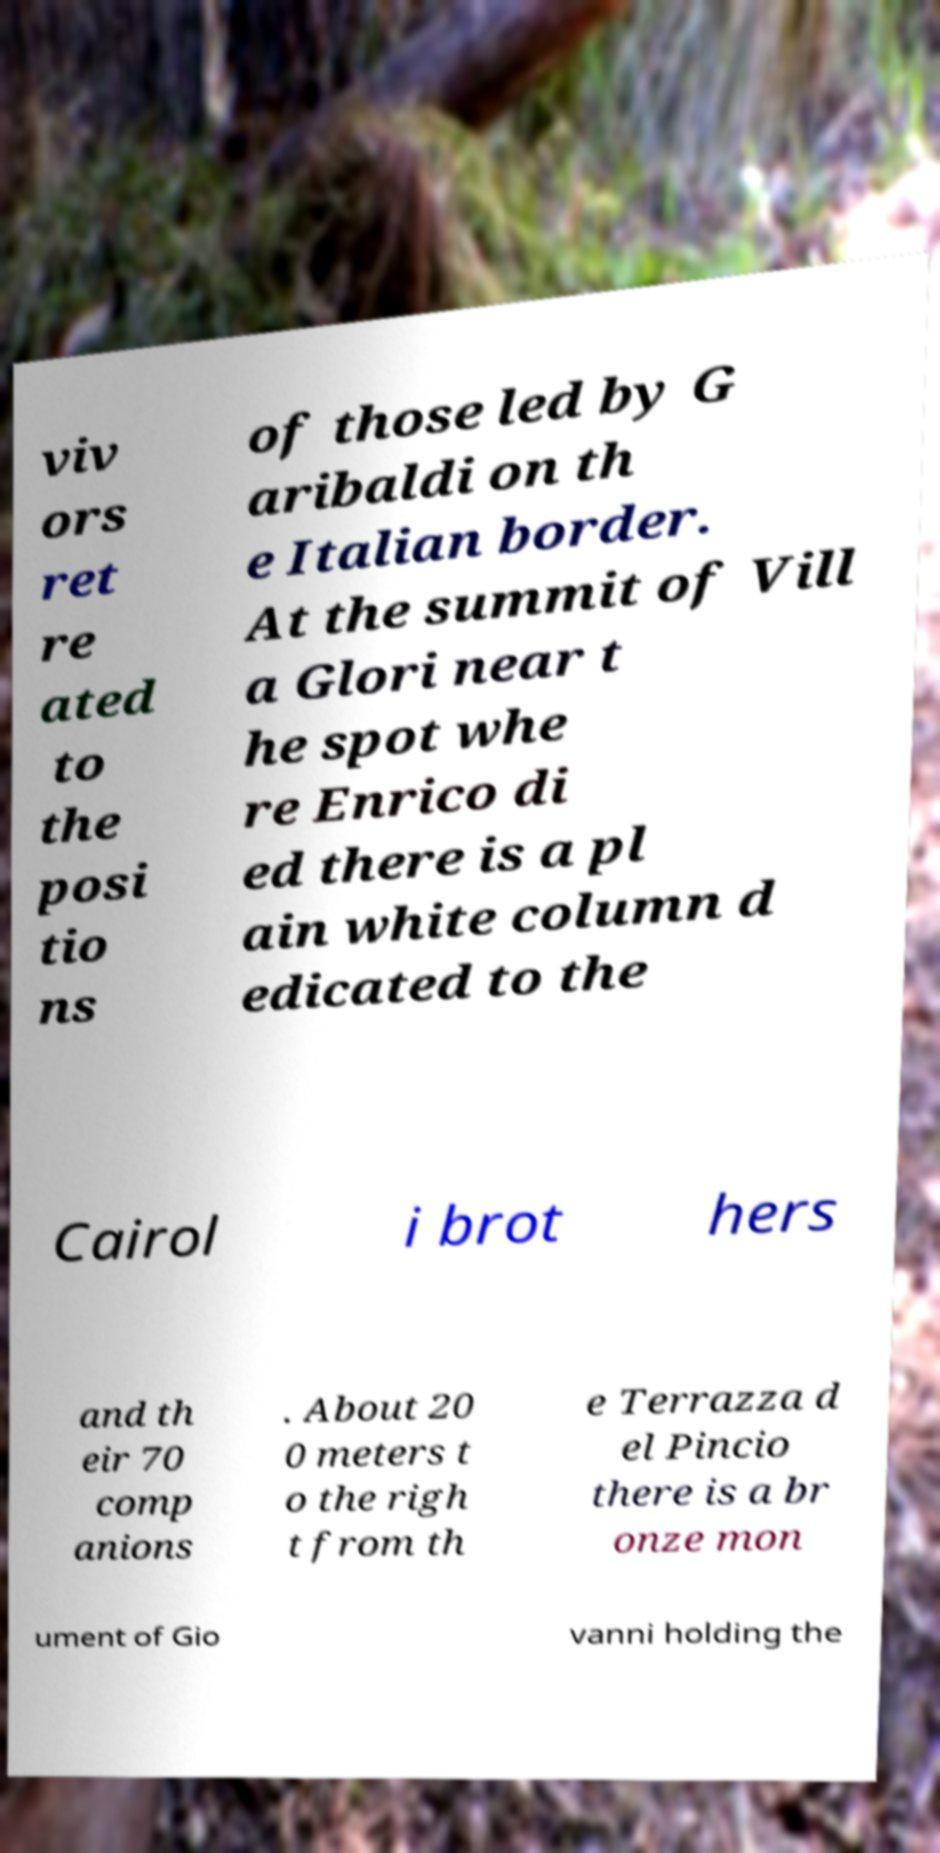For documentation purposes, I need the text within this image transcribed. Could you provide that? viv ors ret re ated to the posi tio ns of those led by G aribaldi on th e Italian border. At the summit of Vill a Glori near t he spot whe re Enrico di ed there is a pl ain white column d edicated to the Cairol i brot hers and th eir 70 comp anions . About 20 0 meters t o the righ t from th e Terrazza d el Pincio there is a br onze mon ument of Gio vanni holding the 